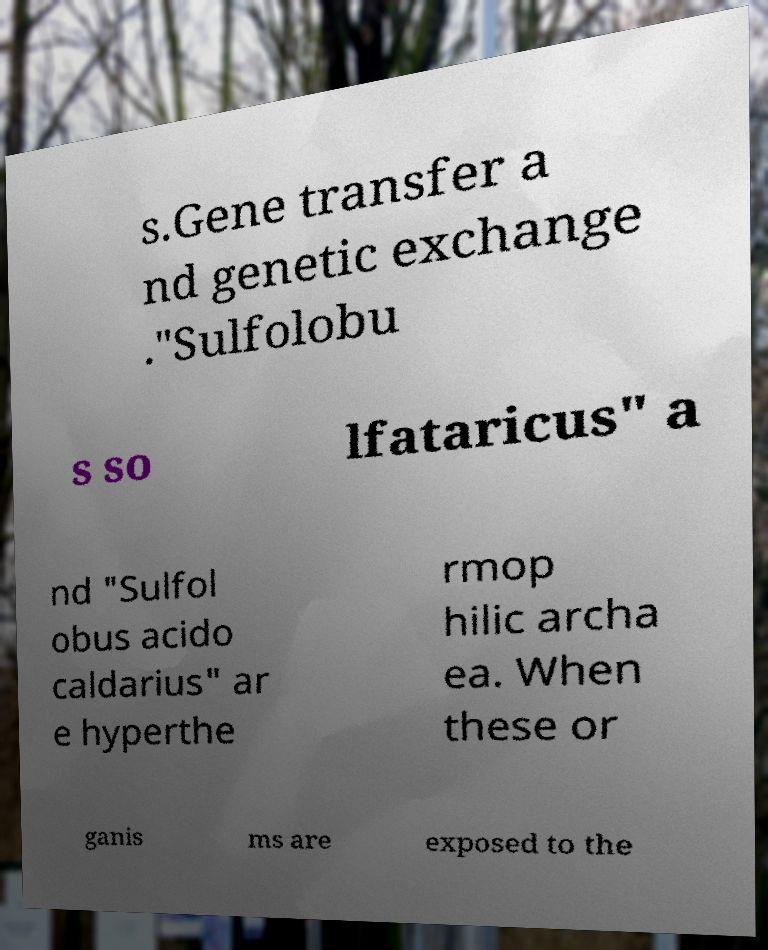Can you accurately transcribe the text from the provided image for me? s.Gene transfer a nd genetic exchange ."Sulfolobu s so lfataricus" a nd "Sulfol obus acido caldarius" ar e hyperthe rmop hilic archa ea. When these or ganis ms are exposed to the 